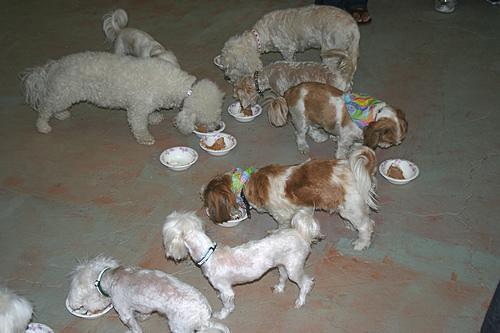How many dogs on the grounds?
Give a very brief answer. 9. 